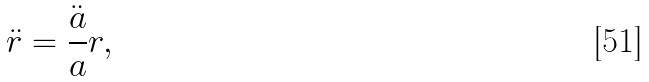<formula> <loc_0><loc_0><loc_500><loc_500>\ddot { r } = \frac { \ddot { a } } a r ,</formula> 